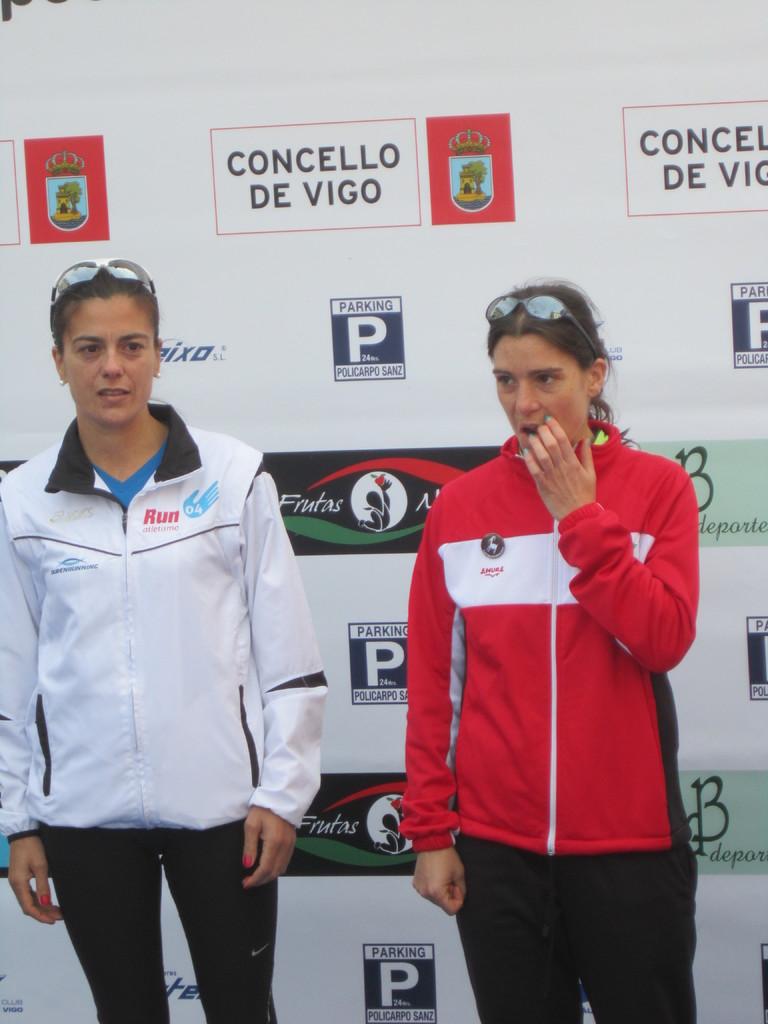What is the sponsor on the top of the wall?
Offer a very short reply. Concello de vigo. What does it say in red letters on the white jacket?
Your answer should be compact. Run. 